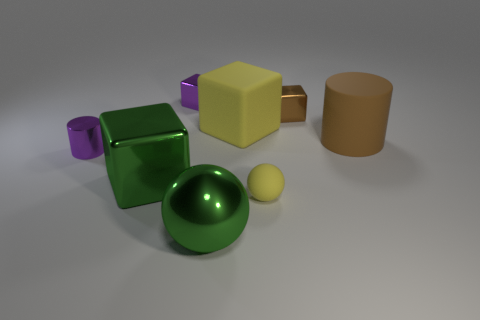Subtract all green cubes. How many cubes are left? 3 Add 2 small blue objects. How many objects exist? 10 Subtract all green blocks. How many blocks are left? 3 Subtract 1 balls. How many balls are left? 1 Subtract all balls. How many objects are left? 6 Subtract 0 red spheres. How many objects are left? 8 Subtract all blue blocks. Subtract all brown cylinders. How many blocks are left? 4 Subtract all tiny purple metallic things. Subtract all large red rubber cylinders. How many objects are left? 6 Add 5 small rubber balls. How many small rubber balls are left? 6 Add 7 big blocks. How many big blocks exist? 9 